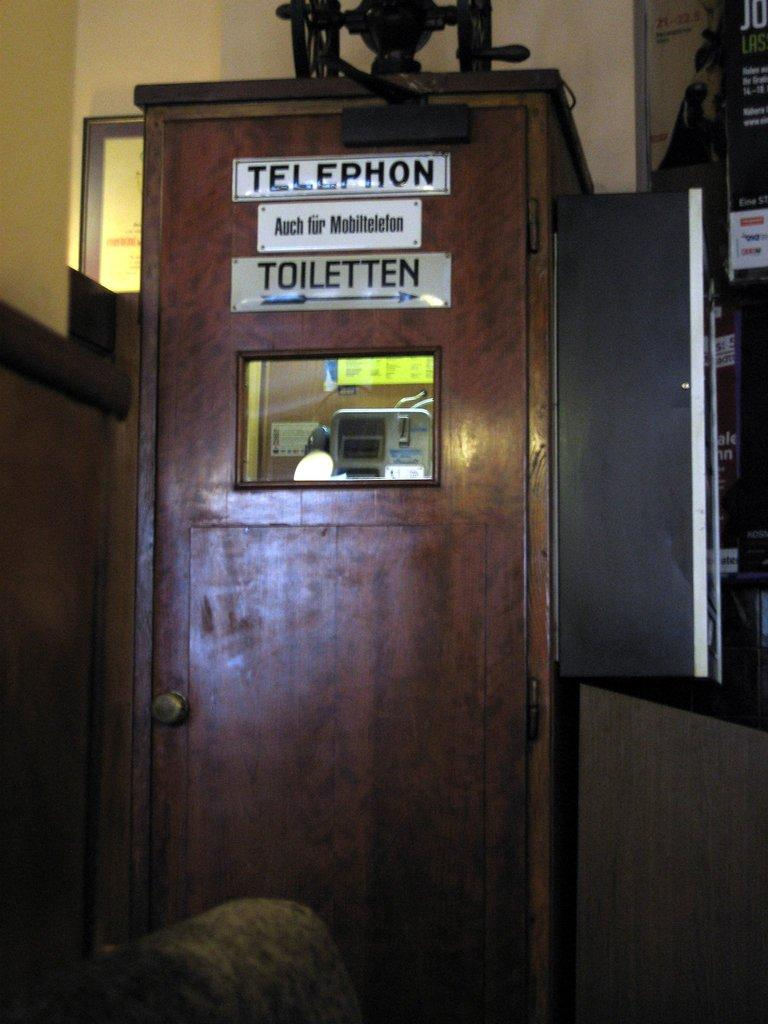What is the main structure in the image? There is a telephone booth in the image. What features can be seen on the telephone booth? The telephone booth has name boards on it and a frame. Are there any additional items on the telephone booth? Yes, there are posters on the telephone booth. What else is present in the image related to the telephone booth? There are objects associated with the telephone booth. What can be seen in the background of the image? The background of the image includes walls. What type of humor can be seen on the posters in the image? There is no humor present on the posters in the image; they are simply posters with no indication of containing humorous content. 